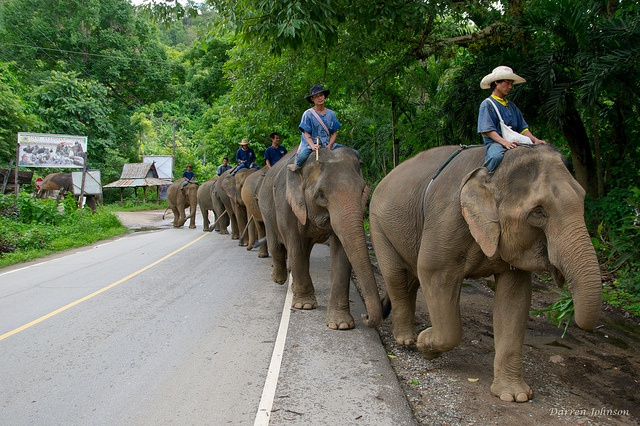Describe the objects in this image and their specific colors. I can see elephant in olive, gray, and black tones, elephant in olive, gray, and black tones, people in olive, black, navy, lightgray, and gray tones, people in olive, black, gray, and blue tones, and elephant in olive, gray, and black tones in this image. 